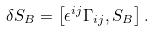<formula> <loc_0><loc_0><loc_500><loc_500>\delta S _ { B } = \left [ \epsilon ^ { i j } \Gamma _ { i j } , S _ { B } \right ] .</formula> 